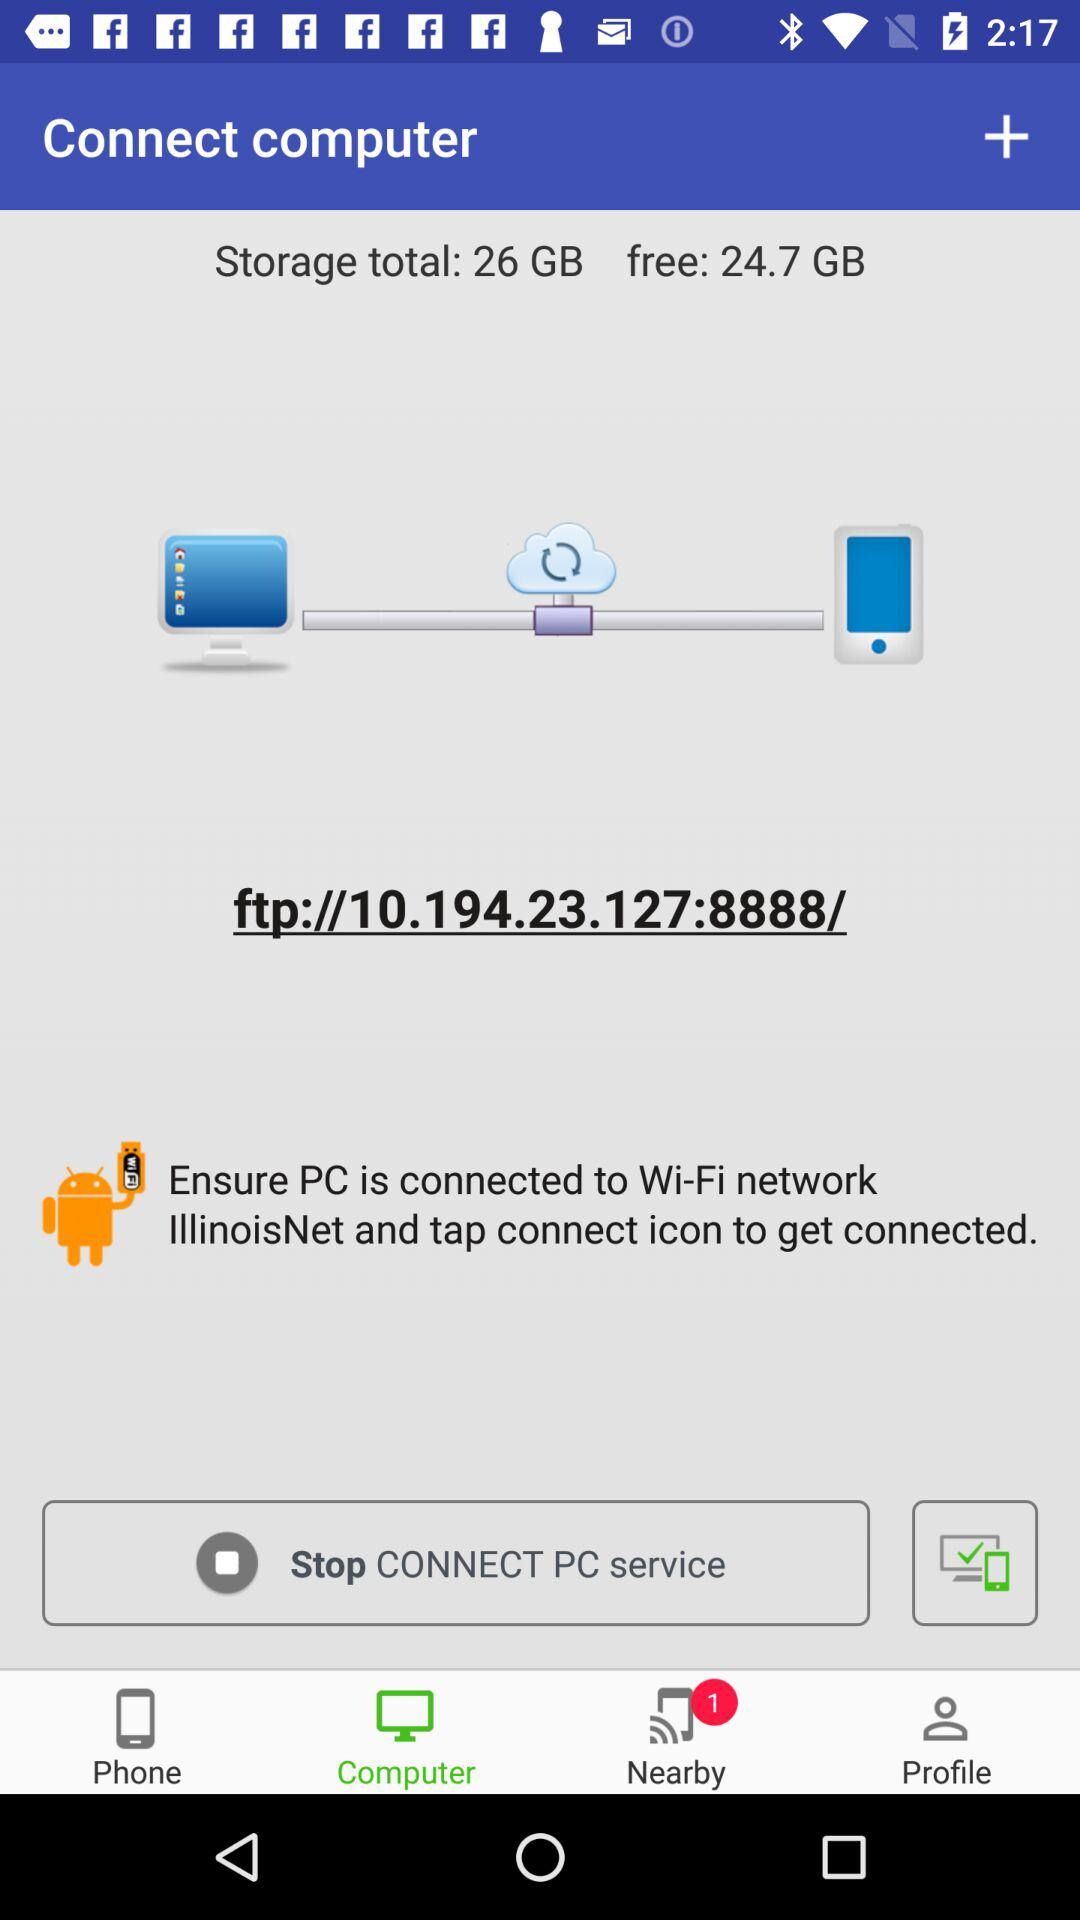How much storage is there in total? The storage is 26 GB in total. 